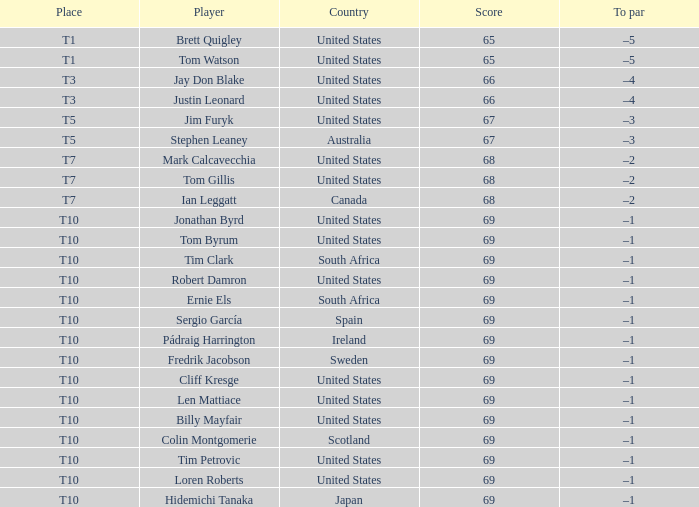What is the average score for the player who is T5 in the United States? 67.0. 